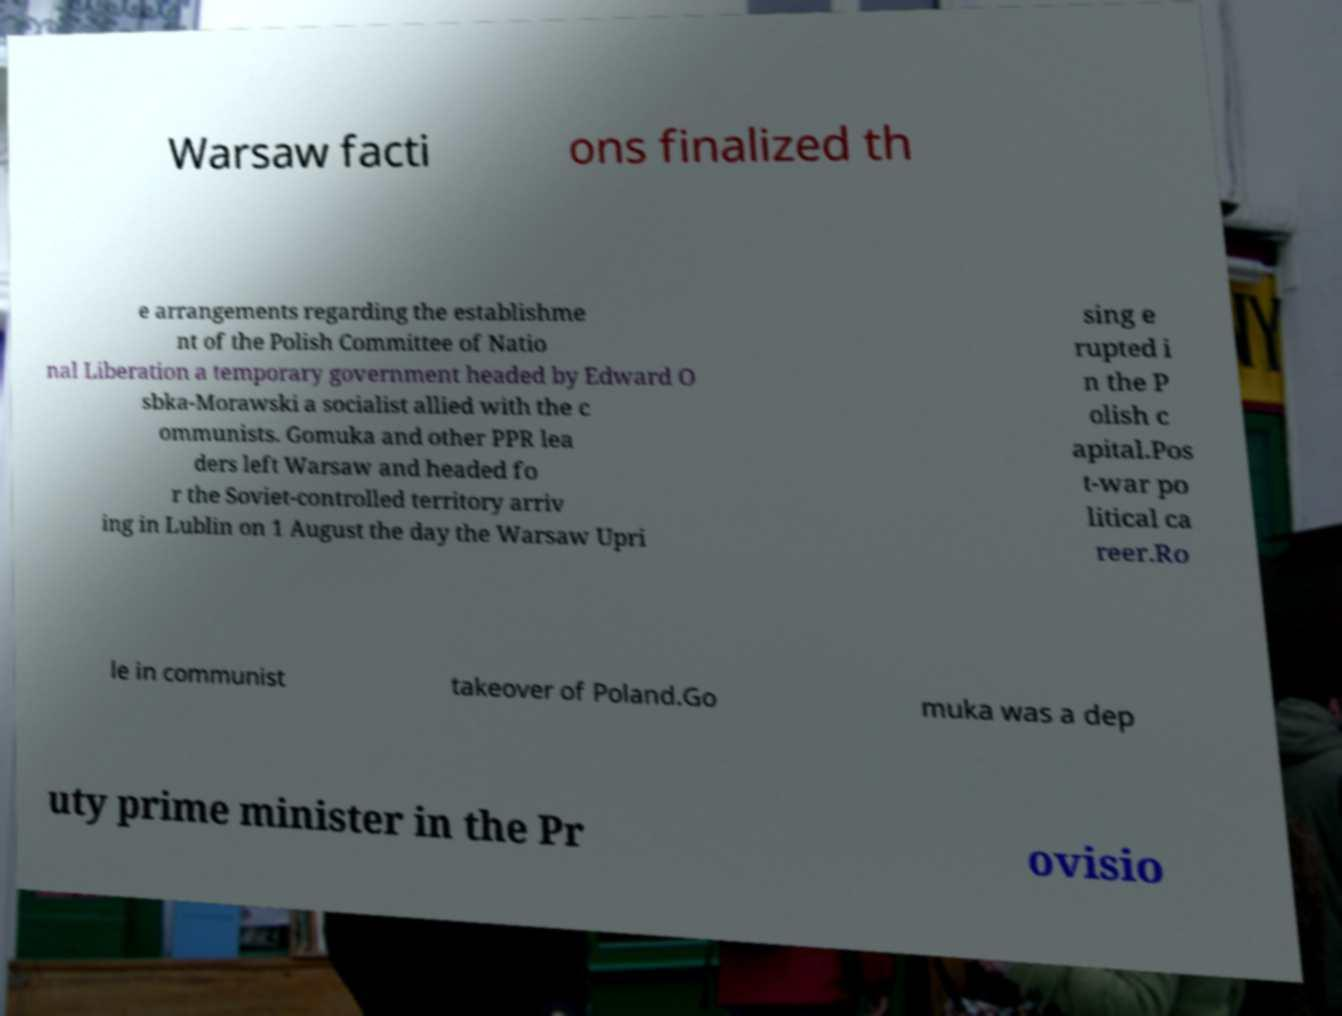Can you read and provide the text displayed in the image?This photo seems to have some interesting text. Can you extract and type it out for me? Warsaw facti ons finalized th e arrangements regarding the establishme nt of the Polish Committee of Natio nal Liberation a temporary government headed by Edward O sbka-Morawski a socialist allied with the c ommunists. Gomuka and other PPR lea ders left Warsaw and headed fo r the Soviet-controlled territory arriv ing in Lublin on 1 August the day the Warsaw Upri sing e rupted i n the P olish c apital.Pos t-war po litical ca reer.Ro le in communist takeover of Poland.Go muka was a dep uty prime minister in the Pr ovisio 